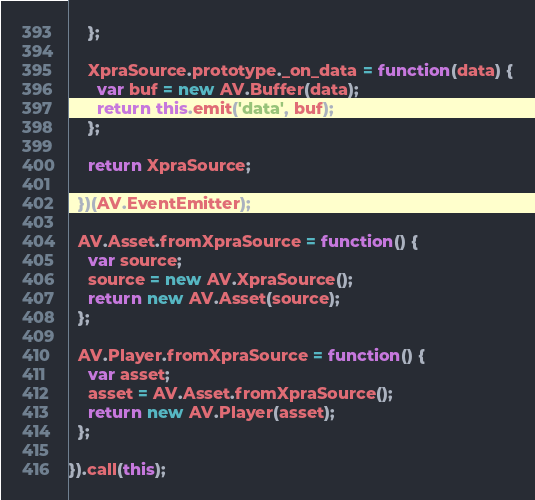Convert code to text. <code><loc_0><loc_0><loc_500><loc_500><_JavaScript_>    };

    XpraSource.prototype._on_data = function(data) {
      var buf = new AV.Buffer(data);
      return this.emit('data', buf);
    };

    return XpraSource;

  })(AV.EventEmitter);

  AV.Asset.fromXpraSource = function() {
    var source;
    source = new AV.XpraSource();
    return new AV.Asset(source);
  };

  AV.Player.fromXpraSource = function() {
    var asset;
    asset = AV.Asset.fromXpraSource();
    return new AV.Player(asset);
  };

}).call(this);</code> 